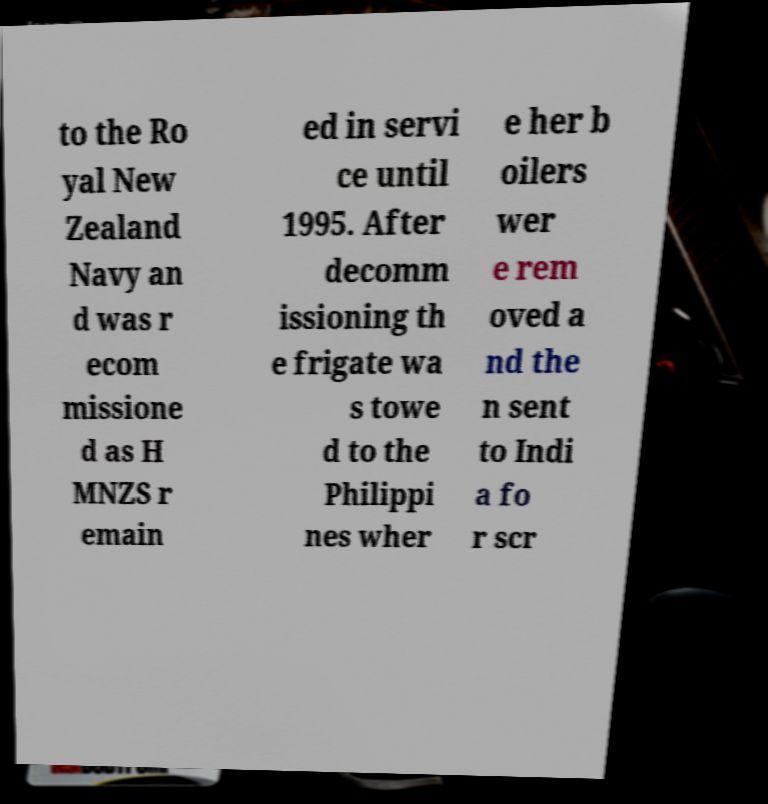Please identify and transcribe the text found in this image. to the Ro yal New Zealand Navy an d was r ecom missione d as H MNZS r emain ed in servi ce until 1995. After decomm issioning th e frigate wa s towe d to the Philippi nes wher e her b oilers wer e rem oved a nd the n sent to Indi a fo r scr 